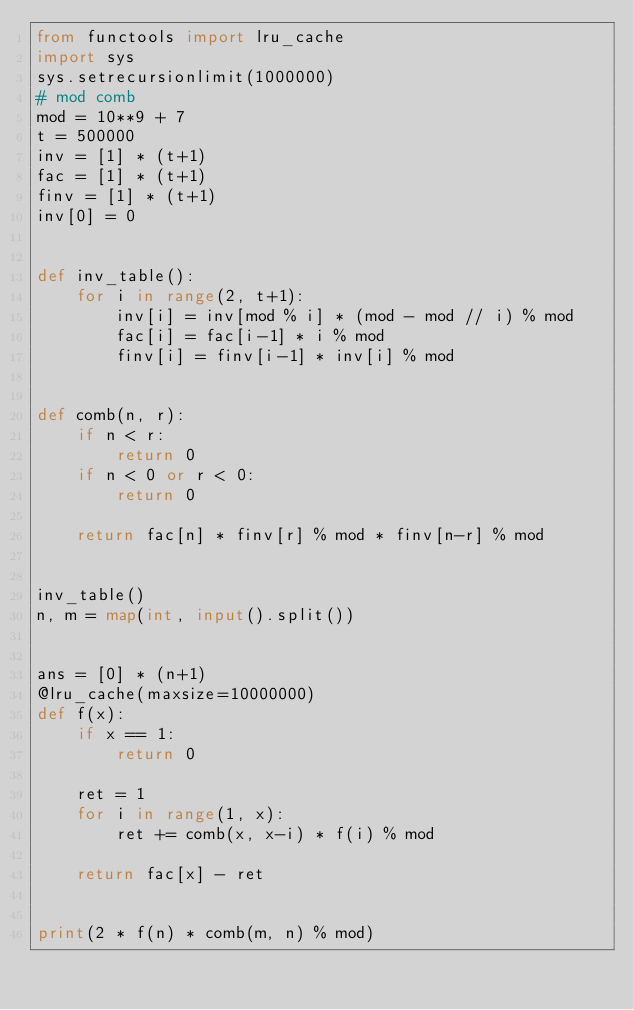<code> <loc_0><loc_0><loc_500><loc_500><_Python_>from functools import lru_cache
import sys
sys.setrecursionlimit(1000000)
# mod comb
mod = 10**9 + 7
t = 500000
inv = [1] * (t+1)
fac = [1] * (t+1)
finv = [1] * (t+1)
inv[0] = 0


def inv_table():
    for i in range(2, t+1):
        inv[i] = inv[mod % i] * (mod - mod // i) % mod
        fac[i] = fac[i-1] * i % mod
        finv[i] = finv[i-1] * inv[i] % mod


def comb(n, r):
    if n < r:
        return 0
    if n < 0 or r < 0:
        return 0

    return fac[n] * finv[r] % mod * finv[n-r] % mod


inv_table()
n, m = map(int, input().split())


ans = [0] * (n+1)
@lru_cache(maxsize=10000000)
def f(x):
    if x == 1:
        return 0

    ret = 1
    for i in range(1, x):
        ret += comb(x, x-i) * f(i) % mod

    return fac[x] - ret


print(2 * f(n) * comb(m, n) % mod)</code> 